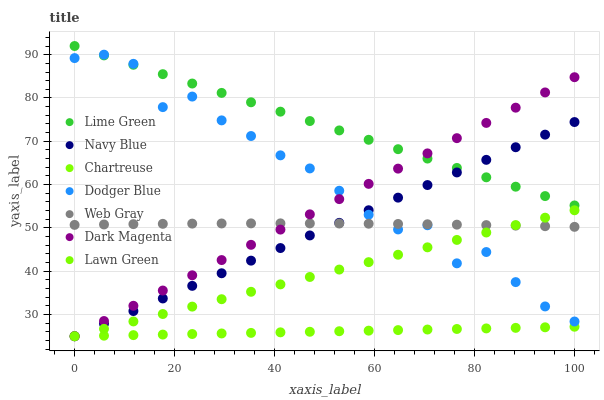Does Chartreuse have the minimum area under the curve?
Answer yes or no. Yes. Does Lime Green have the maximum area under the curve?
Answer yes or no. Yes. Does Web Gray have the minimum area under the curve?
Answer yes or no. No. Does Web Gray have the maximum area under the curve?
Answer yes or no. No. Is Chartreuse the smoothest?
Answer yes or no. Yes. Is Dodger Blue the roughest?
Answer yes or no. Yes. Is Web Gray the smoothest?
Answer yes or no. No. Is Web Gray the roughest?
Answer yes or no. No. Does Lawn Green have the lowest value?
Answer yes or no. Yes. Does Web Gray have the lowest value?
Answer yes or no. No. Does Lime Green have the highest value?
Answer yes or no. Yes. Does Web Gray have the highest value?
Answer yes or no. No. Is Chartreuse less than Web Gray?
Answer yes or no. Yes. Is Lime Green greater than Lawn Green?
Answer yes or no. Yes. Does Dodger Blue intersect Web Gray?
Answer yes or no. Yes. Is Dodger Blue less than Web Gray?
Answer yes or no. No. Is Dodger Blue greater than Web Gray?
Answer yes or no. No. Does Chartreuse intersect Web Gray?
Answer yes or no. No. 